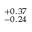<formula> <loc_0><loc_0><loc_500><loc_500>^ { + 0 . 3 7 } _ { - 0 . 2 4 }</formula> 